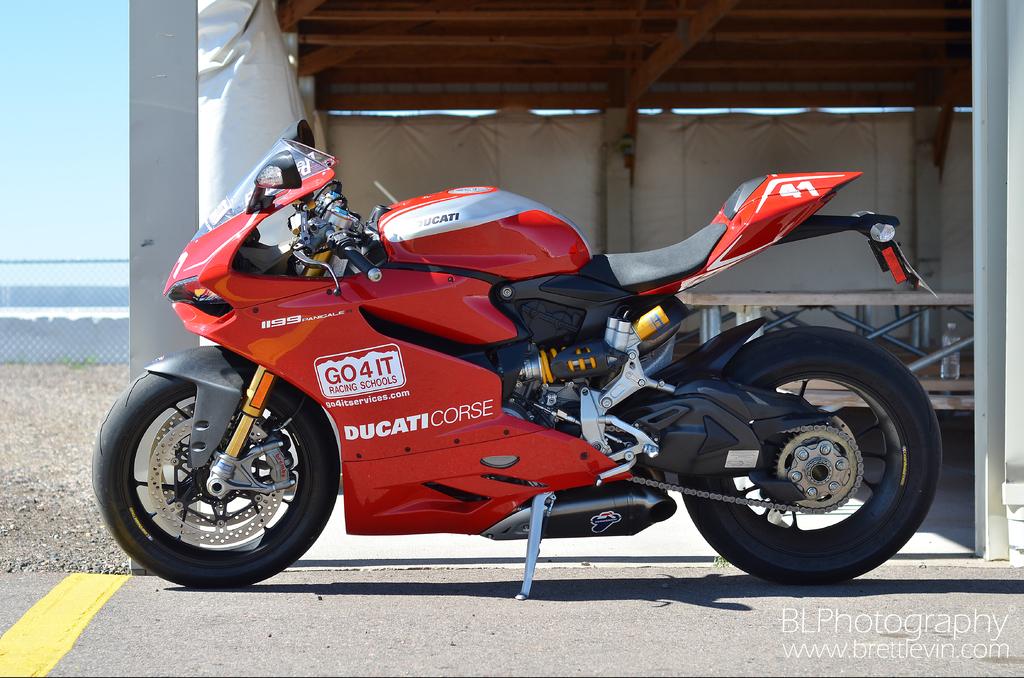What kind of motorcycle is this?
Provide a short and direct response. Ducati. 